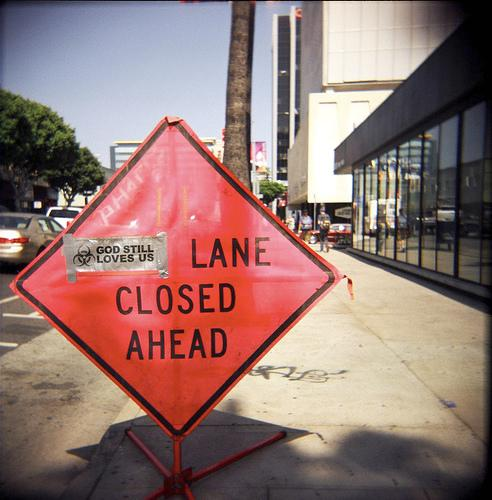How was something added to this sign most recently? Please explain your reasoning. tape. There is a sticker attached to the sign. 